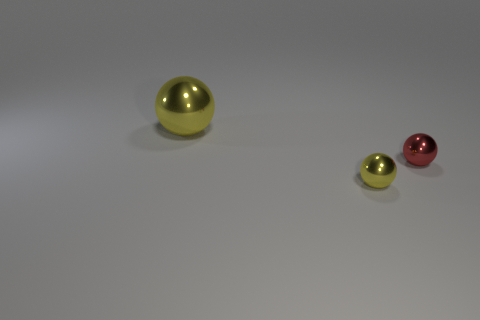Does the big metal object have the same shape as the tiny yellow thing?
Your answer should be very brief. Yes. Does the large shiny object have the same shape as the yellow metallic thing that is in front of the big yellow object?
Offer a terse response. Yes. The small metal object behind the yellow object in front of the yellow sphere that is behind the tiny red ball is what color?
Give a very brief answer. Red. Do the yellow shiny thing that is in front of the large ball and the red metal object have the same shape?
Provide a succinct answer. Yes. What is the tiny yellow object made of?
Provide a succinct answer. Metal. What shape is the tiny thing that is in front of the small sphere to the right of the metal object that is in front of the red shiny ball?
Keep it short and to the point. Sphere. What number of other things are the same shape as the big yellow object?
Keep it short and to the point. 2. Is the color of the big thing the same as the metal thing in front of the small red thing?
Give a very brief answer. Yes. What number of large spheres are there?
Offer a very short reply. 1. How many objects are brown things or small metal spheres?
Your answer should be very brief. 2. 